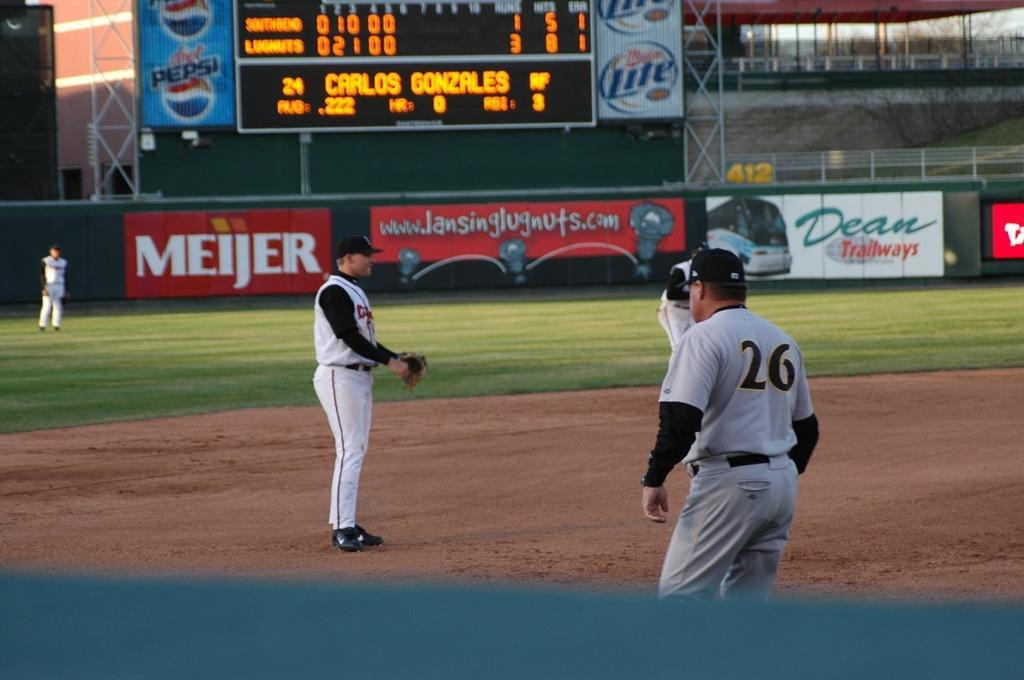In one or two sentences, can you explain what this image depicts? In the picture we can see a playground with some part with plane surface and some part with green color mat and three people are standing on it with sportswear and black caps and in the background, we can see a wall with advertisements and on it we can see a score board and beside it we can see a shed with pillars to it and around it we can see the railing. 